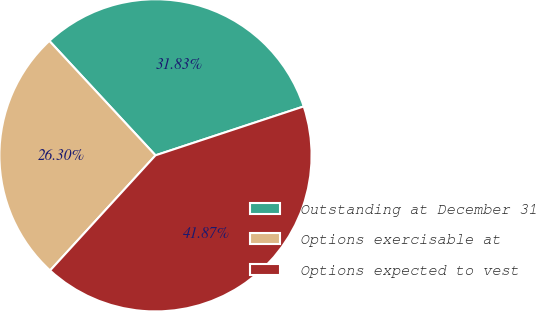<chart> <loc_0><loc_0><loc_500><loc_500><pie_chart><fcel>Outstanding at December 31<fcel>Options exercisable at<fcel>Options expected to vest<nl><fcel>31.83%<fcel>26.3%<fcel>41.87%<nl></chart> 